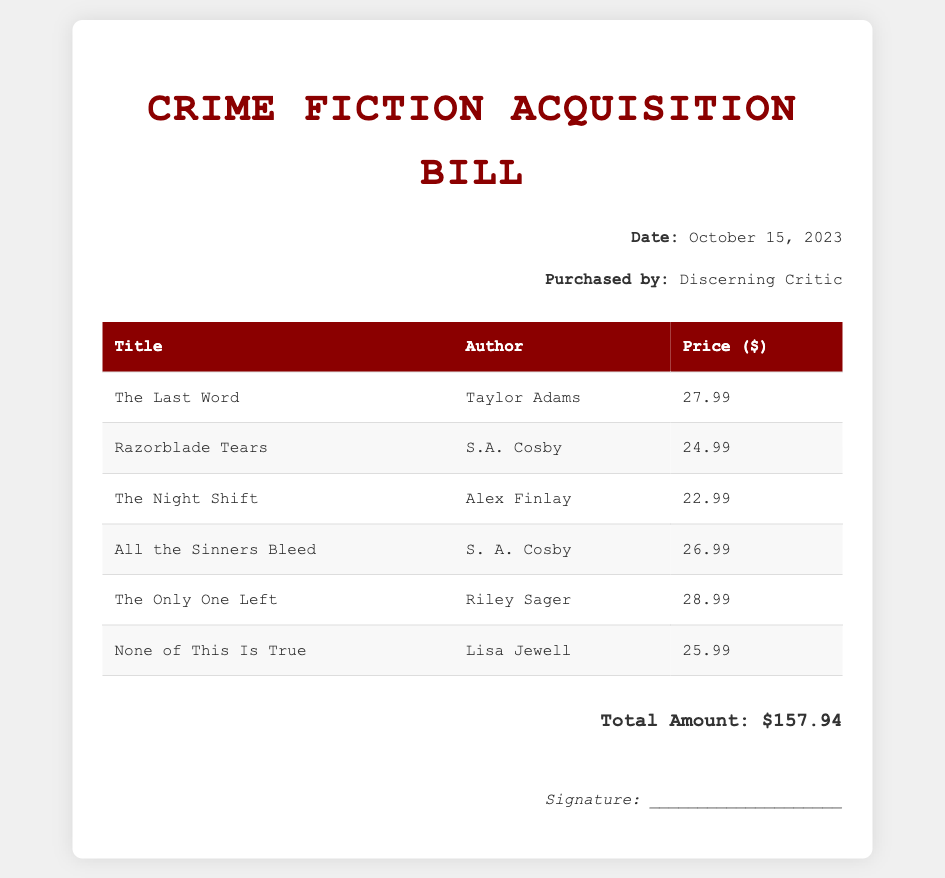What is the title of the first book listed? The title of the first book in the list is mentioned in the first row of the table.
Answer: The Last Word Who is the author of "Razorblade Tears"? The author is found in the second row corresponding to the title "Razorblade Tears".
Answer: S.A. Cosby What is the purchase price of "The Only One Left"? The purchase price can be found in the table next to the title "The Only One Left".
Answer: 28.99 How many books are listed in the bill? The total number of books is counted from the number of rows in the table, excluding the header.
Answer: 6 What is the total amount spent on the books? The total amount is provided as a summary at the bottom of the document.
Answer: 157.94 What date was the bill issued? The date appears prominently at the top right section of the document.
Answer: October 15, 2023 Which author has two titles listed in the document? By examining the author column in the table, one can identify that one specific author is repeated.
Answer: S. A. Cosby Who is the purchaser of this bill? The purchaser's name is provided directly below the date in the header section.
Answer: Discerning Critic 